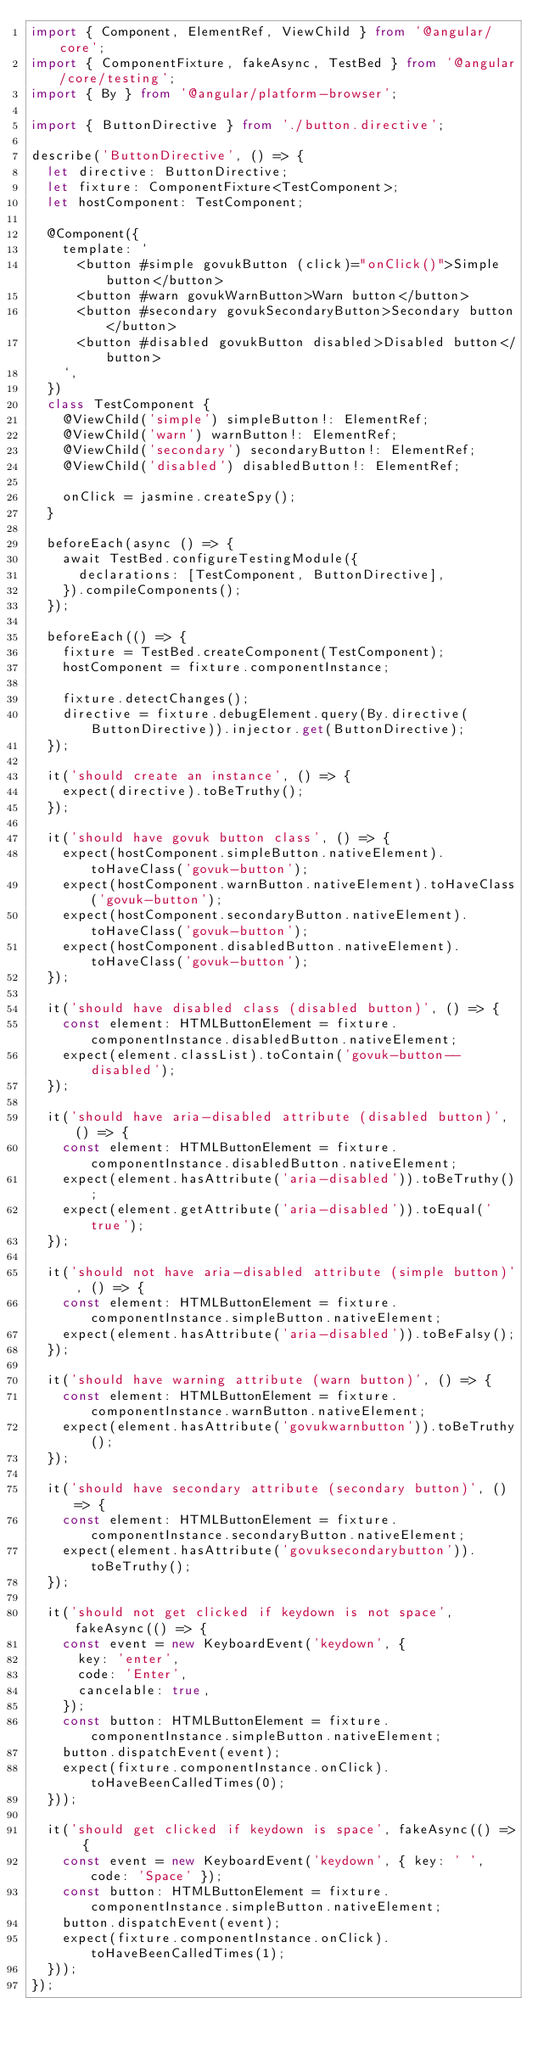<code> <loc_0><loc_0><loc_500><loc_500><_TypeScript_>import { Component, ElementRef, ViewChild } from '@angular/core';
import { ComponentFixture, fakeAsync, TestBed } from '@angular/core/testing';
import { By } from '@angular/platform-browser';

import { ButtonDirective } from './button.directive';

describe('ButtonDirective', () => {
  let directive: ButtonDirective;
  let fixture: ComponentFixture<TestComponent>;
  let hostComponent: TestComponent;

  @Component({
    template: `
      <button #simple govukButton (click)="onClick()">Simple button</button>
      <button #warn govukWarnButton>Warn button</button>
      <button #secondary govukSecondaryButton>Secondary button</button>
      <button #disabled govukButton disabled>Disabled button</button>
    `,
  })
  class TestComponent {
    @ViewChild('simple') simpleButton!: ElementRef;
    @ViewChild('warn') warnButton!: ElementRef;
    @ViewChild('secondary') secondaryButton!: ElementRef;
    @ViewChild('disabled') disabledButton!: ElementRef;

    onClick = jasmine.createSpy();
  }

  beforeEach(async () => {
    await TestBed.configureTestingModule({
      declarations: [TestComponent, ButtonDirective],
    }).compileComponents();
  });

  beforeEach(() => {
    fixture = TestBed.createComponent(TestComponent);
    hostComponent = fixture.componentInstance;

    fixture.detectChanges();
    directive = fixture.debugElement.query(By.directive(ButtonDirective)).injector.get(ButtonDirective);
  });

  it('should create an instance', () => {
    expect(directive).toBeTruthy();
  });

  it('should have govuk button class', () => {
    expect(hostComponent.simpleButton.nativeElement).toHaveClass('govuk-button');
    expect(hostComponent.warnButton.nativeElement).toHaveClass('govuk-button');
    expect(hostComponent.secondaryButton.nativeElement).toHaveClass('govuk-button');
    expect(hostComponent.disabledButton.nativeElement).toHaveClass('govuk-button');
  });

  it('should have disabled class (disabled button)', () => {
    const element: HTMLButtonElement = fixture.componentInstance.disabledButton.nativeElement;
    expect(element.classList).toContain('govuk-button--disabled');
  });

  it('should have aria-disabled attribute (disabled button)', () => {
    const element: HTMLButtonElement = fixture.componentInstance.disabledButton.nativeElement;
    expect(element.hasAttribute('aria-disabled')).toBeTruthy();
    expect(element.getAttribute('aria-disabled')).toEqual('true');
  });

  it('should not have aria-disabled attribute (simple button)', () => {
    const element: HTMLButtonElement = fixture.componentInstance.simpleButton.nativeElement;
    expect(element.hasAttribute('aria-disabled')).toBeFalsy();
  });

  it('should have warning attribute (warn button)', () => {
    const element: HTMLButtonElement = fixture.componentInstance.warnButton.nativeElement;
    expect(element.hasAttribute('govukwarnbutton')).toBeTruthy();
  });

  it('should have secondary attribute (secondary button)', () => {
    const element: HTMLButtonElement = fixture.componentInstance.secondaryButton.nativeElement;
    expect(element.hasAttribute('govuksecondarybutton')).toBeTruthy();
  });

  it('should not get clicked if keydown is not space', fakeAsync(() => {
    const event = new KeyboardEvent('keydown', {
      key: 'enter',
      code: 'Enter',
      cancelable: true,
    });
    const button: HTMLButtonElement = fixture.componentInstance.simpleButton.nativeElement;
    button.dispatchEvent(event);
    expect(fixture.componentInstance.onClick).toHaveBeenCalledTimes(0);
  }));

  it('should get clicked if keydown is space', fakeAsync(() => {
    const event = new KeyboardEvent('keydown', { key: ' ', code: 'Space' });
    const button: HTMLButtonElement = fixture.componentInstance.simpleButton.nativeElement;
    button.dispatchEvent(event);
    expect(fixture.componentInstance.onClick).toHaveBeenCalledTimes(1);
  }));
});
</code> 